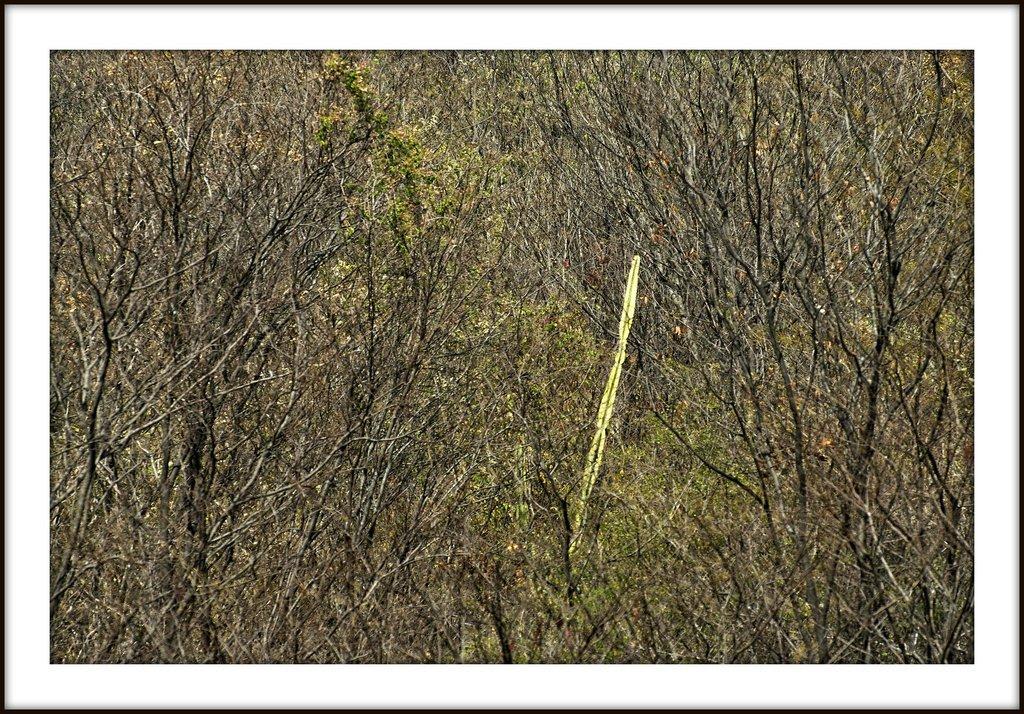Could you give a brief overview of what you see in this image? In this image we can see bare trees. 